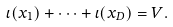Convert formula to latex. <formula><loc_0><loc_0><loc_500><loc_500>\iota ( x _ { 1 } ) + \dots + \iota ( x _ { D } ) = V .</formula> 